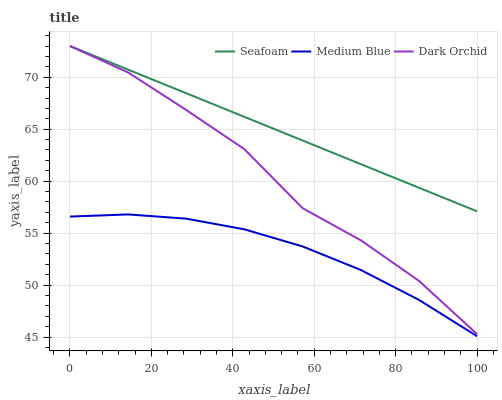Does Medium Blue have the minimum area under the curve?
Answer yes or no. Yes. Does Seafoam have the maximum area under the curve?
Answer yes or no. Yes. Does Dark Orchid have the minimum area under the curve?
Answer yes or no. No. Does Dark Orchid have the maximum area under the curve?
Answer yes or no. No. Is Seafoam the smoothest?
Answer yes or no. Yes. Is Dark Orchid the roughest?
Answer yes or no. Yes. Is Dark Orchid the smoothest?
Answer yes or no. No. Is Seafoam the roughest?
Answer yes or no. No. Does Medium Blue have the lowest value?
Answer yes or no. Yes. Does Dark Orchid have the lowest value?
Answer yes or no. No. Does Dark Orchid have the highest value?
Answer yes or no. Yes. Is Medium Blue less than Dark Orchid?
Answer yes or no. Yes. Is Seafoam greater than Medium Blue?
Answer yes or no. Yes. Does Seafoam intersect Dark Orchid?
Answer yes or no. Yes. Is Seafoam less than Dark Orchid?
Answer yes or no. No. Is Seafoam greater than Dark Orchid?
Answer yes or no. No. Does Medium Blue intersect Dark Orchid?
Answer yes or no. No. 